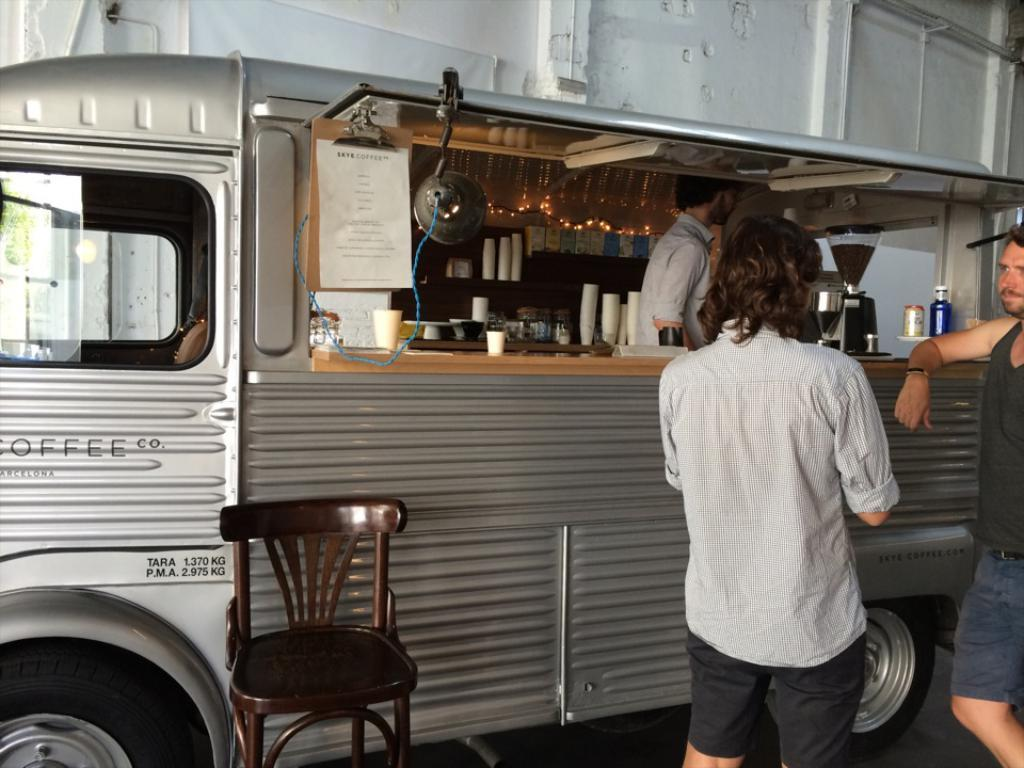How many people are in the image? There are three persons in the image. What are two of the persons doing in the image? Two of the persons are standing outside a truck. What type of furniture is present in the image? There is a chair in the image. What type of stationery item is present in the image? There is a notebook in the image. What type of tableware is present in the image? There are glasses in the image. What type of equipment is present in the image? There is a machine in the image. What type of pain can be seen on the faces of the persons in the image? There is no indication of pain on the faces of the persons in the image. How many trees are visible in the image? There are no trees visible in the image. What is the daughter of the person standing outside the truck doing in the image? There is no mention of a daughter or any other family members in the image. 